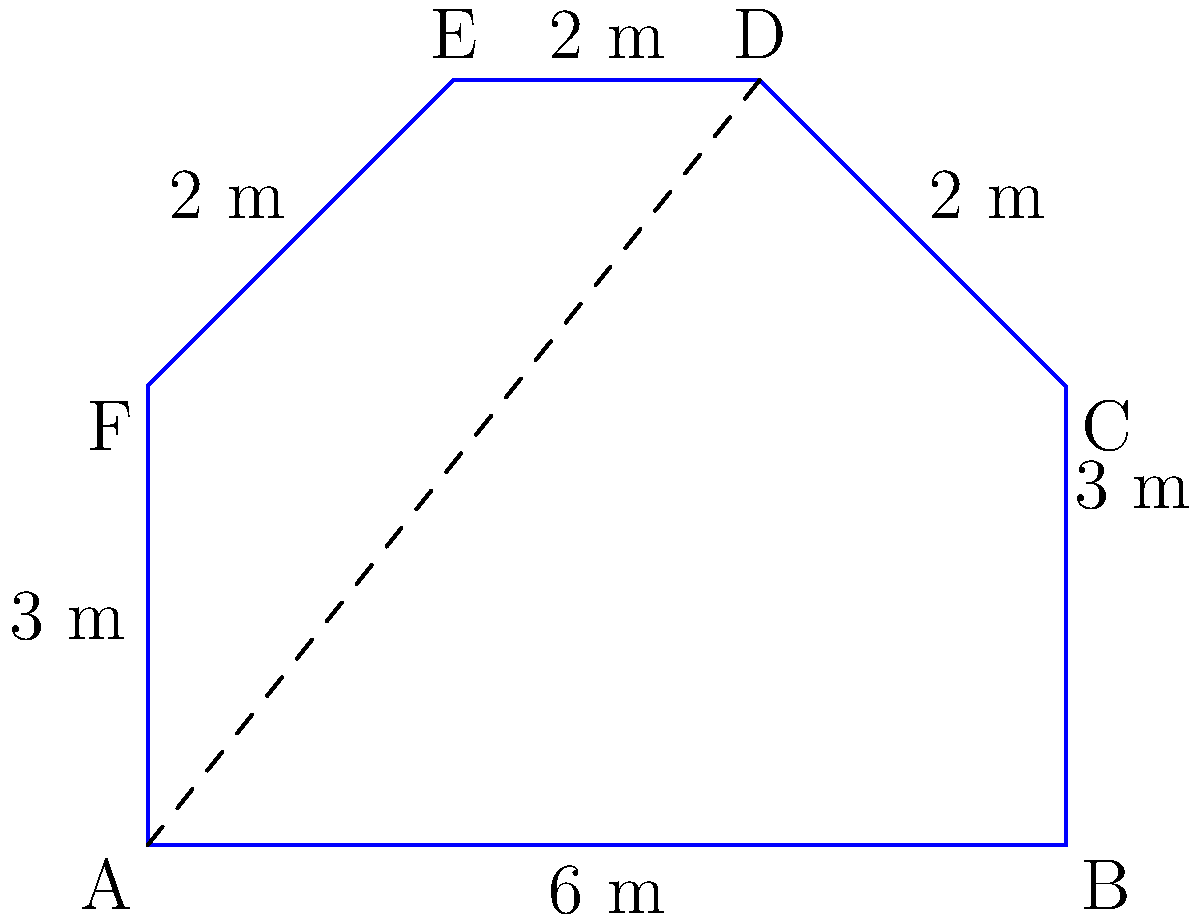While photographing an irregularly shaped plaza in Buenos Aires, you decide to calculate its area. The plaza can be decomposed into a rectangle and two triangles, as shown in the diagram. Given the measurements provided, what is the total area of the plaza in square meters? Let's break down the calculation step by step:

1) First, we'll divide the plaza into three parts: a rectangle (ABCF) and two triangles (CDE and ADF).

2) Calculate the area of the rectangle ABCF:
   Length = 6 m, Width = 3 m
   Area of rectangle = $6 \times 3 = 18$ m²

3) Calculate the area of triangle CDE:
   Base = 2 m, Height = 2 m
   Area of CDE = $\frac{1}{2} \times 2 \times 2 = 2$ m²

4) Calculate the area of triangle ADF:
   Base = 2 m, Height = 2 m
   Area of ADF = $\frac{1}{2} \times 2 \times 2 = 2$ m²

5) Sum up all the areas:
   Total Area = Area of rectangle + Area of CDE + Area of ADF
               = $18 + 2 + 2 = 22$ m²

Therefore, the total area of the plaza is 22 square meters.
Answer: 22 m² 